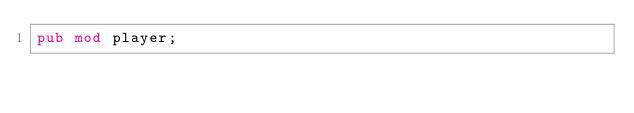Convert code to text. <code><loc_0><loc_0><loc_500><loc_500><_Rust_>pub mod player;
</code> 